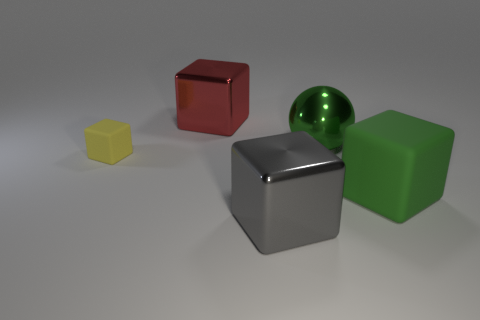There is a big object that is the same color as the big metal ball; what material is it?
Keep it short and to the point. Rubber. What material is the gray object that is the same shape as the red metallic thing?
Your answer should be very brief. Metal. How many large things have the same color as the large metallic sphere?
Your answer should be compact. 1. There is a gray shiny thing; is it the same shape as the green thing right of the shiny ball?
Offer a very short reply. Yes. Do the rubber thing on the right side of the big red cube and the big red thing have the same shape?
Provide a short and direct response. Yes. What is the material of the small yellow cube?
Make the answer very short. Rubber. There is a sphere; does it have the same color as the big object right of the green ball?
Give a very brief answer. Yes. There is a small yellow matte thing; what number of big blocks are left of it?
Provide a succinct answer. 0. Is the number of yellow rubber things that are right of the tiny yellow matte cube less than the number of brown rubber spheres?
Ensure brevity in your answer.  No. The large sphere has what color?
Provide a short and direct response. Green. 